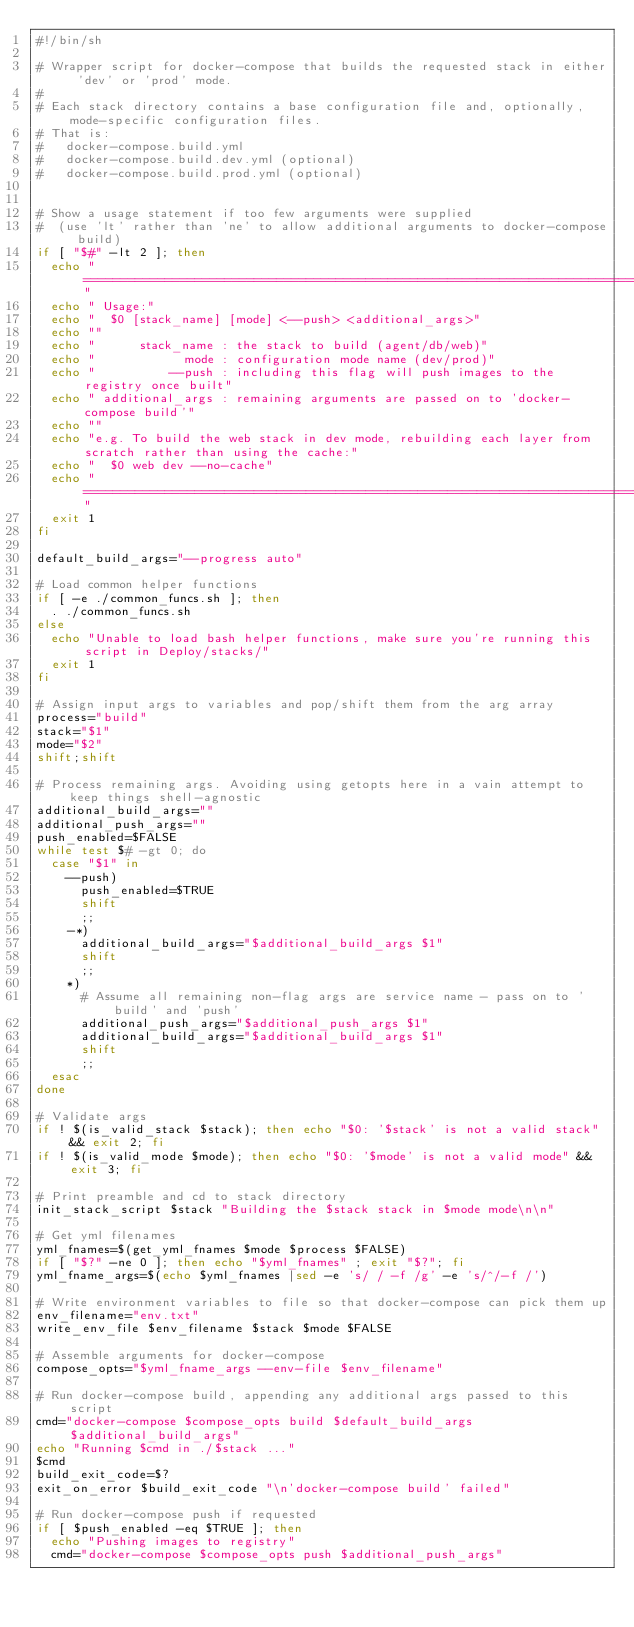<code> <loc_0><loc_0><loc_500><loc_500><_Bash_>#!/bin/sh

# Wrapper script for docker-compose that builds the requested stack in either 'dev' or 'prod' mode.
#
# Each stack directory contains a base configuration file and, optionally, mode-specific configuration files.
# That is:
#   docker-compose.build.yml
#   docker-compose.build.dev.yml (optional)
#   docker-compose.build.prod.yml (optional)


# Show a usage statement if too few arguments were supplied
#  (use 'lt' rather than 'ne' to allow additional arguments to docker-compose build)
if [ "$#" -lt 2 ]; then
  echo "============================================================================="
  echo " Usage:"
  echo "  $0 [stack_name] [mode] <--push> <additional_args>"
  echo ""
  echo "      stack_name : the stack to build (agent/db/web)"
  echo "            mode : configuration mode name (dev/prod)"
  echo "          --push : including this flag will push images to the registry once built"
  echo " additional_args : remaining arguments are passed on to 'docker-compose build'"
  echo ""
  echo "e.g. To build the web stack in dev mode, rebuilding each layer from scratch rather than using the cache:"
  echo "  $0 web dev --no-cache"
  echo "============================================================================="
  exit 1
fi

default_build_args="--progress auto"

# Load common helper functions
if [ -e ./common_funcs.sh ]; then
  . ./common_funcs.sh
else
  echo "Unable to load bash helper functions, make sure you're running this script in Deploy/stacks/"
  exit 1
fi

# Assign input args to variables and pop/shift them from the arg array
process="build"
stack="$1"
mode="$2"
shift;shift

# Process remaining args. Avoiding using getopts here in a vain attempt to keep things shell-agnostic
additional_build_args=""
additional_push_args=""
push_enabled=$FALSE
while test $# -gt 0; do
  case "$1" in
    --push)
      push_enabled=$TRUE
      shift
      ;;
    -*)
      additional_build_args="$additional_build_args $1"
      shift
      ;;
    *)
      # Assume all remaining non-flag args are service name - pass on to 'build' and 'push'
      additional_push_args="$additional_push_args $1"
      additional_build_args="$additional_build_args $1"
      shift
      ;;
  esac
done

# Validate args
if ! $(is_valid_stack $stack); then echo "$0: '$stack' is not a valid stack" && exit 2; fi
if ! $(is_valid_mode $mode); then echo "$0: '$mode' is not a valid mode" && exit 3; fi

# Print preamble and cd to stack directory
init_stack_script $stack "Building the $stack stack in $mode mode\n\n"

# Get yml filenames
yml_fnames=$(get_yml_fnames $mode $process $FALSE)
if [ "$?" -ne 0 ]; then echo "$yml_fnames" ; exit "$?"; fi
yml_fname_args=$(echo $yml_fnames |sed -e 's/ / -f /g' -e 's/^/-f /')

# Write environment variables to file so that docker-compose can pick them up
env_filename="env.txt"
write_env_file $env_filename $stack $mode $FALSE

# Assemble arguments for docker-compose
compose_opts="$yml_fname_args --env-file $env_filename"

# Run docker-compose build, appending any additional args passed to this script
cmd="docker-compose $compose_opts build $default_build_args $additional_build_args"
echo "Running $cmd in ./$stack ..."
$cmd
build_exit_code=$?
exit_on_error $build_exit_code "\n'docker-compose build' failed"

# Run docker-compose push if requested
if [ $push_enabled -eq $TRUE ]; then
  echo "Pushing images to registry"
  cmd="docker-compose $compose_opts push $additional_push_args"</code> 